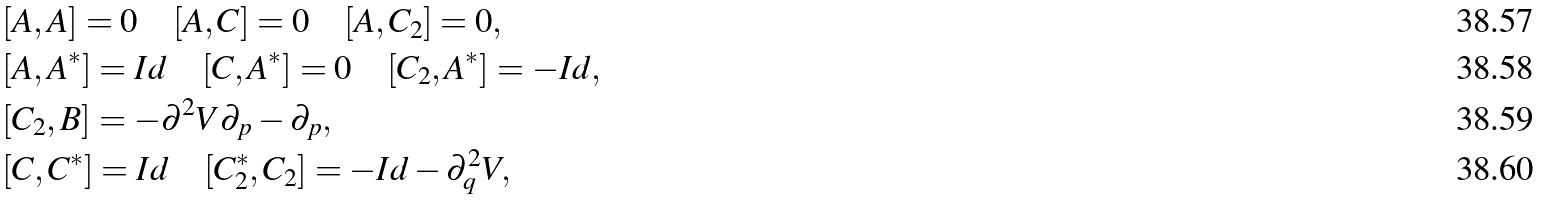Convert formula to latex. <formula><loc_0><loc_0><loc_500><loc_500>& [ A , A ] = 0 \quad [ A , C ] = 0 \quad [ A , C _ { 2 } ] = 0 , \\ & [ A , A ^ { * } ] = I d \quad [ C , A ^ { * } ] = 0 \quad [ C _ { 2 } , A ^ { * } ] = - I d , \\ & [ C _ { 2 } , B ] = - \partial ^ { 2 } V \partial _ { p } - \partial _ { p } , \quad \\ & [ C , C ^ { * } ] = I d \quad [ C _ { 2 } ^ { * } , C _ { 2 } ] = - I d - \partial _ { q } ^ { 2 } V ,</formula> 